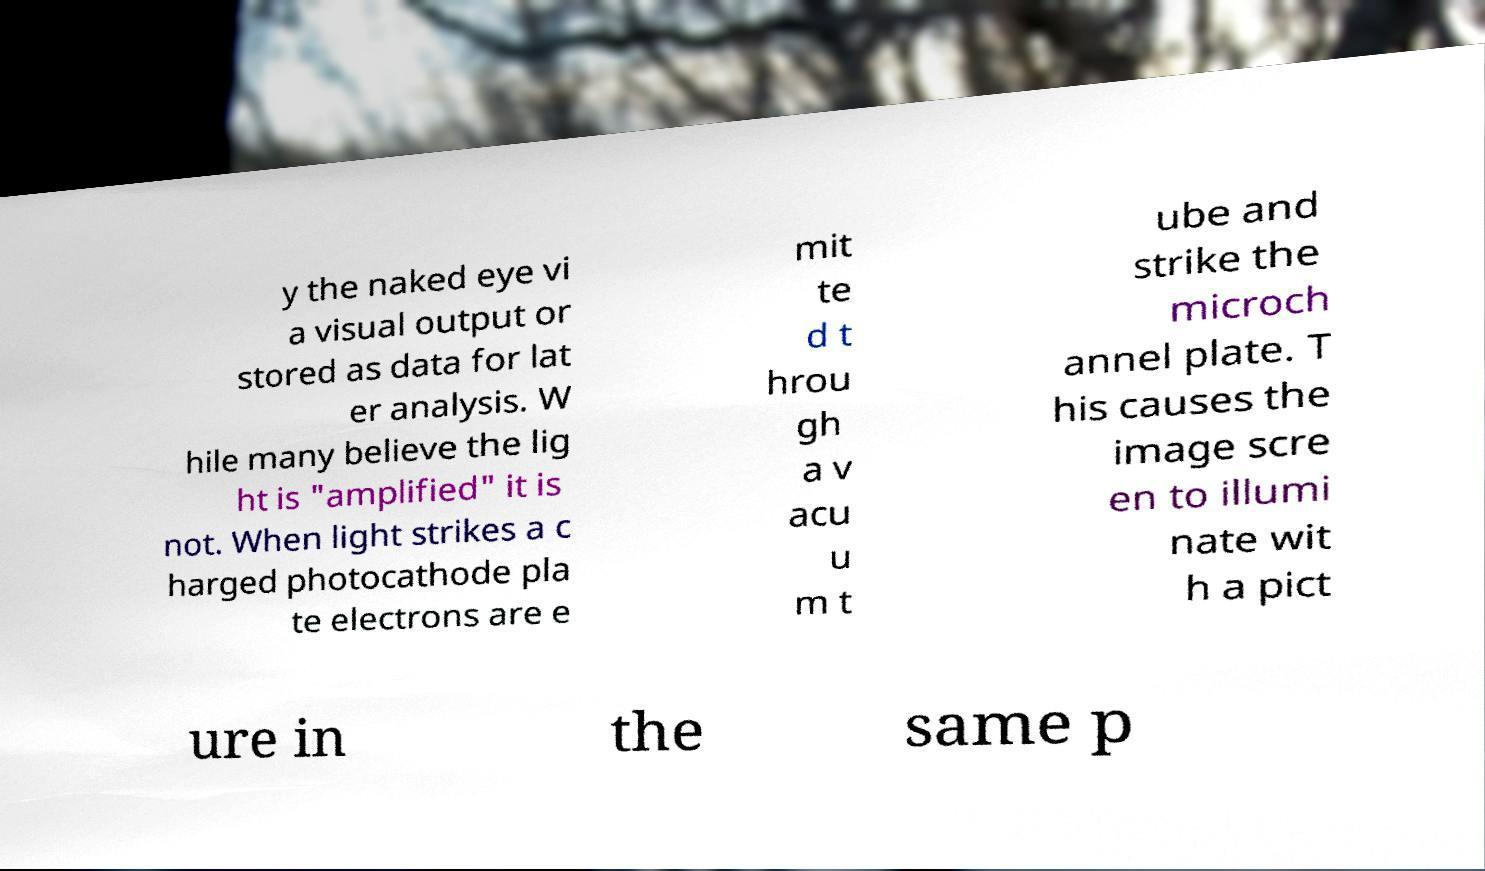Please read and relay the text visible in this image. What does it say? y the naked eye vi a visual output or stored as data for lat er analysis. W hile many believe the lig ht is "amplified" it is not. When light strikes a c harged photocathode pla te electrons are e mit te d t hrou gh a v acu u m t ube and strike the microch annel plate. T his causes the image scre en to illumi nate wit h a pict ure in the same p 